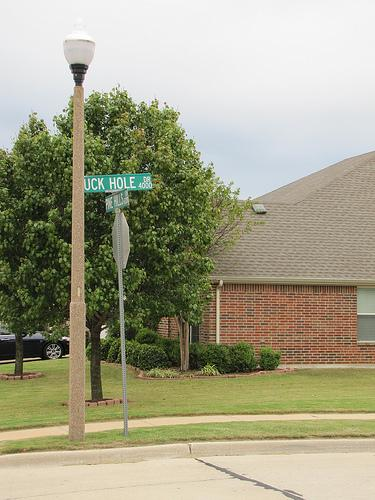Describe the car and its surroundings in the image. A black car is parked in the driveway beside a gray cement sidewalk, with a rubber and metal car tire visible, and it's near a tree with red bricks around it. Provide a brief description of the main elements in the image. A brick house, tall green tree, street signs, stop sign, lamp post, black car, sidewalk, and green lawn are all visible in the scene. Give a general description of the scene in the image. The image displays a brick house with a tall green tree beside it, various street signs, followed by a neatly maintained green lawn, a parked car, and a clear road. Explore the picture and provide a description about trees and grass. There is a tall green tree with a red brick base and another smaller tree nearby, surrounded by a nicely mowed green grassy lawn with well-trimmed grass patches. Explain what is happening with the street signs and the stop sign. There are three street signs on a metal sign post, including a silver metal stop sign and two green signs with white writing, all positioned above the stop sign. Describe the outside area of the house in the image. A gray cement sidewalk runs beside the brick house, with shrubbery landscaping around the house and other objects like street signs, lamp post, tree, and a parked car. Comment on the image while focusing on the lamp post and its features. A very tall lamp post stands near the house with a white bulb, the light post is positioned at the side of the road and its height is emphasized as being tall. Describe the scene in the image while focusing on the house. A brick house with a window, red brick landscaping, and shrubbery around has a tree beside it and a tall lamp post nearby, with a sidewalk running next to the house. Mention the main objects in the image and describe their colors. The image contains a red brick house, a tall green tree, a very tall lamp post, a black car on driveway, green signs with white writing, and a neatly maintained green grass. Focus on the components of the image featuring windows, stop sign, and gutter. A glass window with white trim is visible on the house, along with the back of a stop sign and a white metal gutter downspout connected to a drain of a rain gutter. 